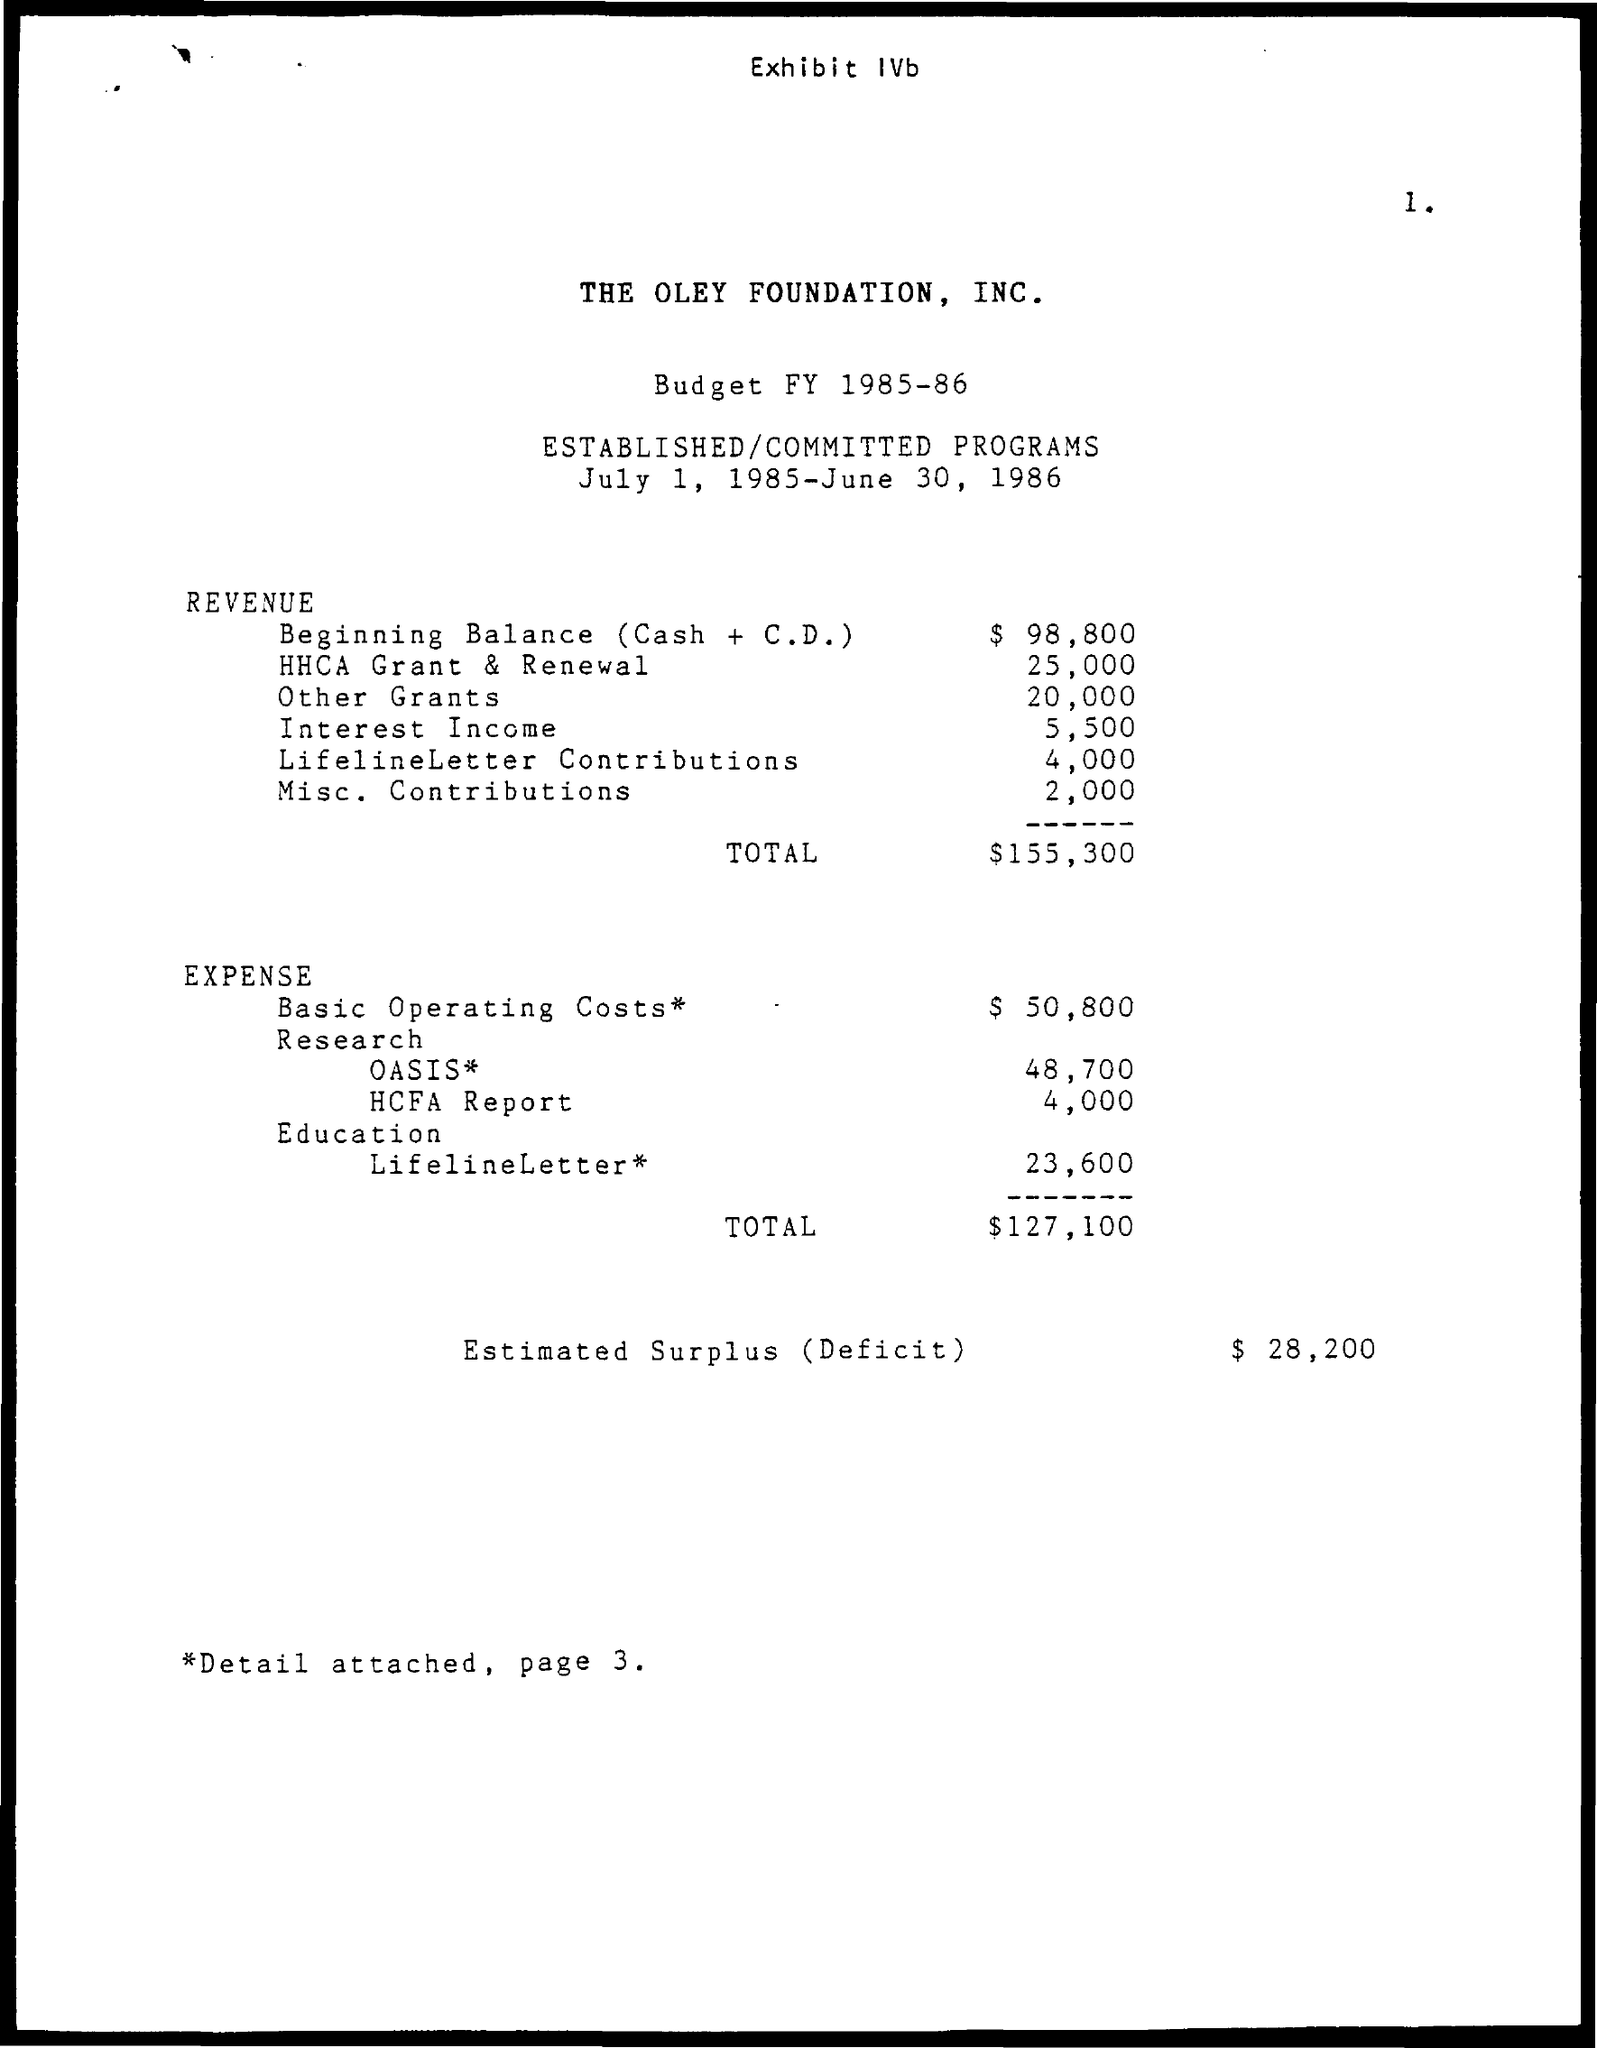Mention a couple of crucial points in this snapshot. The budget for interest income, as mentioned in the given revenue, is 5,500. The expenditure for basic operating costs amounted to $50,800. The given revenue includes a total budget of $155,300. The amount budgeted for the HHCA grant and renewal, as stated in the given revenue, is $25,000. The beginning balance (cash plus certificate of deposit) shown in the revenue is $98,800. 